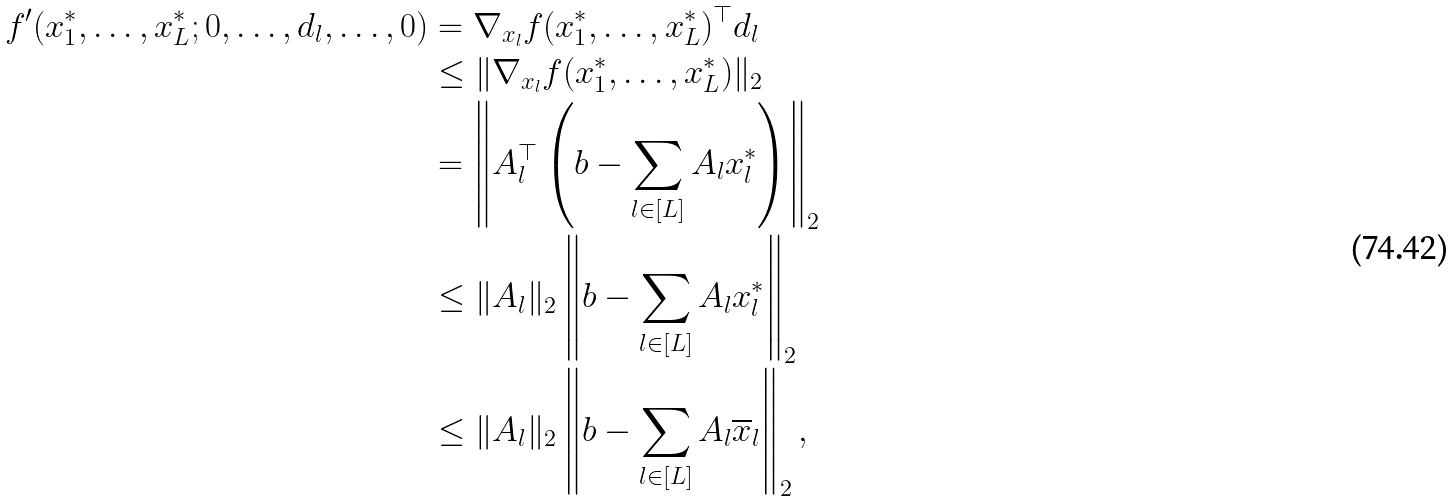<formula> <loc_0><loc_0><loc_500><loc_500>f ^ { \prime } ( x _ { 1 } ^ { * } , \dots , x _ { L } ^ { * } ; 0 , \dots , d _ { l } , \dots , 0 ) & = \nabla _ { x _ { l } } f ( x _ { 1 } ^ { * } , \dots , x _ { L } ^ { * } ) ^ { \top } d _ { l } \\ & \leq \| \nabla _ { x _ { l } } f ( x _ { 1 } ^ { * } , \dots , x _ { L } ^ { * } ) \| _ { 2 } \\ & = \left \| A _ { l } ^ { \top } \left ( b - \sum _ { l \in [ L ] } A _ { l } x _ { l } ^ { * } \right ) \right \| _ { 2 } \\ & \leq \| A _ { l } \| _ { 2 } \left \| b - \sum _ { l \in [ L ] } A _ { l } x _ { l } ^ { * } \right \| _ { 2 } \\ & \leq \| A _ { l } \| _ { 2 } \left \| b - \sum _ { l \in [ L ] } A _ { l } \overline { x } _ { l } \right \| _ { 2 } ,</formula> 